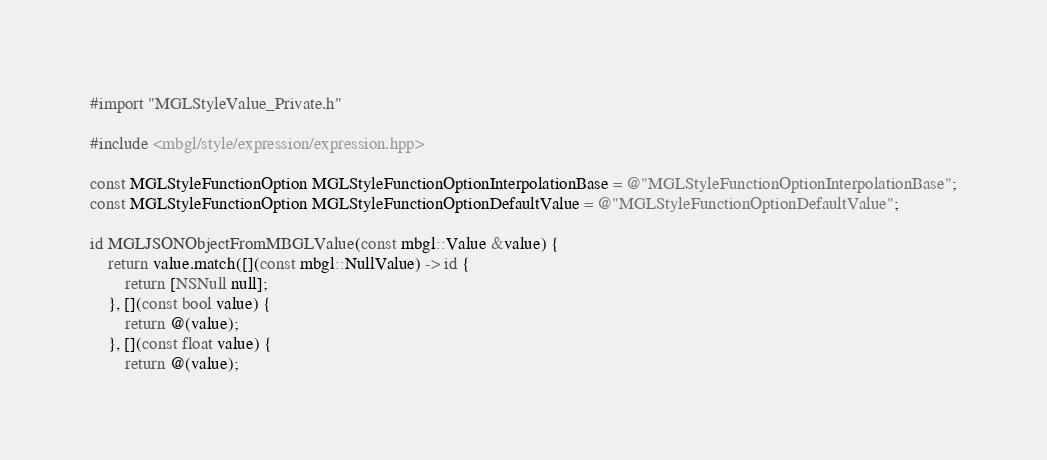Convert code to text. <code><loc_0><loc_0><loc_500><loc_500><_ObjectiveC_>#import "MGLStyleValue_Private.h"

#include <mbgl/style/expression/expression.hpp>

const MGLStyleFunctionOption MGLStyleFunctionOptionInterpolationBase = @"MGLStyleFunctionOptionInterpolationBase";
const MGLStyleFunctionOption MGLStyleFunctionOptionDefaultValue = @"MGLStyleFunctionOptionDefaultValue";

id MGLJSONObjectFromMBGLValue(const mbgl::Value &value) {
    return value.match([](const mbgl::NullValue) -> id {
        return [NSNull null];
    }, [](const bool value) {
        return @(value);
    }, [](const float value) {
        return @(value);</code> 